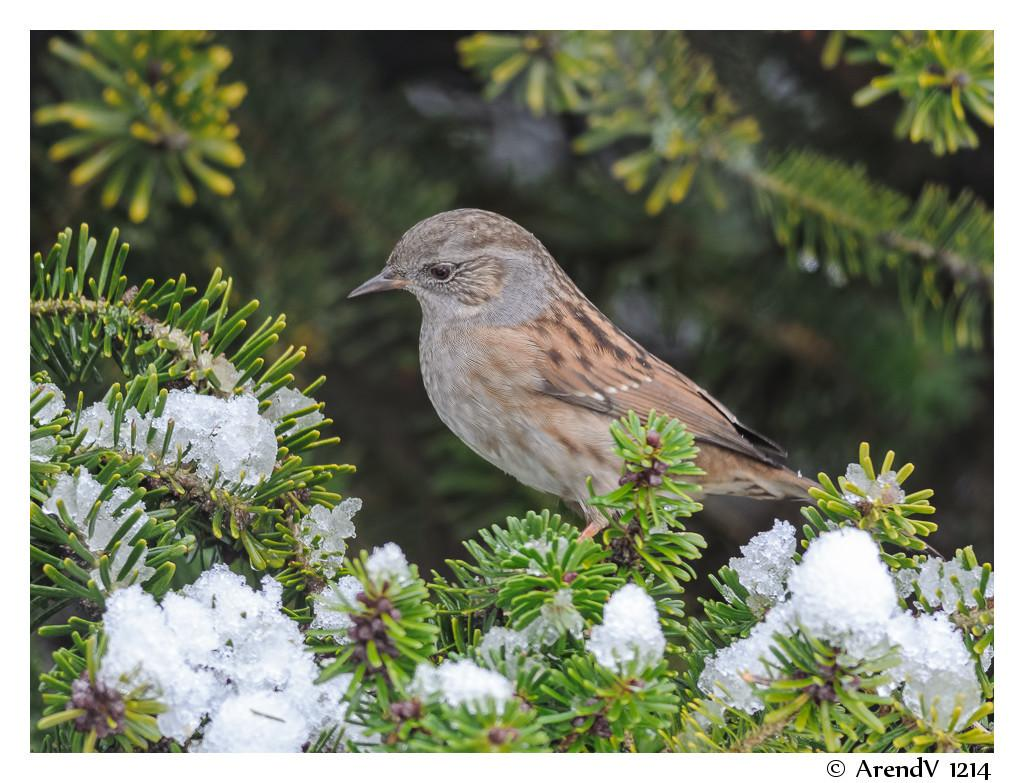What type of bird can be seen in the image? There is a small brown color bird in the image. Where is the bird located in the image? The bird is sitting on green plants. Can you describe the background of the image? The background of the image is blurred. What type of learning material is the bird using in the image? There is no learning material present in the image, as it features a small brown color bird sitting on green plants. 